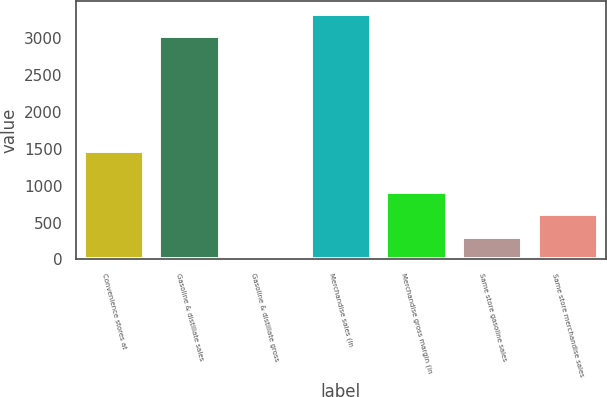Convert chart. <chart><loc_0><loc_0><loc_500><loc_500><bar_chart><fcel>Convenience stores at<fcel>Gasoline & distillate sales<fcel>Gasoline & distillate gross<fcel>Merchandise sales (in<fcel>Merchandise gross margin (in<fcel>Same store gasoline sales<fcel>Same store merchandise sales<nl><fcel>1464<fcel>3027<fcel>0.13<fcel>3332.79<fcel>917.5<fcel>305.92<fcel>611.71<nl></chart> 